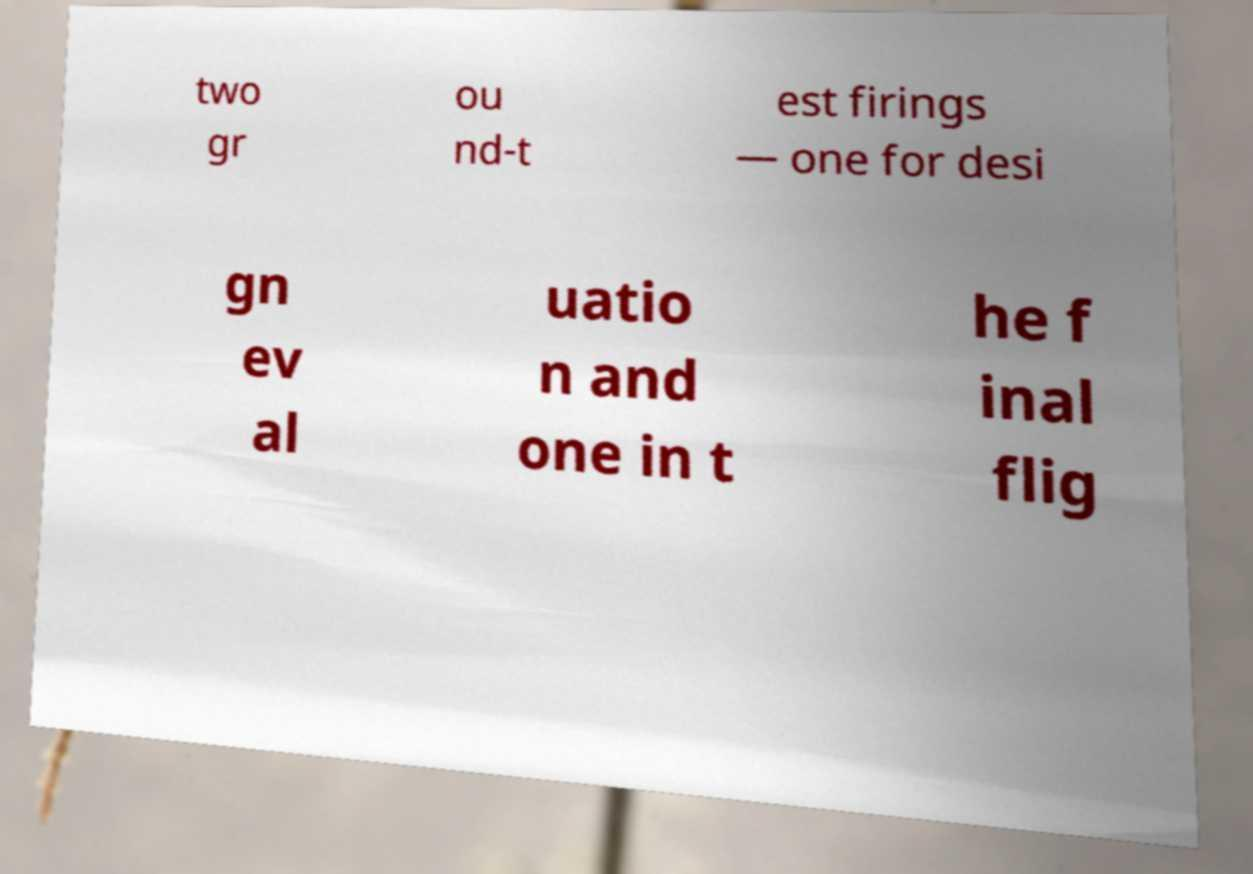What messages or text are displayed in this image? I need them in a readable, typed format. two gr ou nd-t est firings — one for desi gn ev al uatio n and one in t he f inal flig 